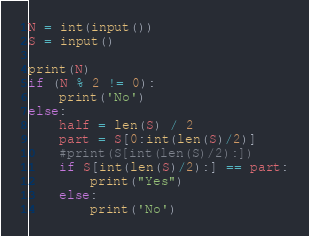<code> <loc_0><loc_0><loc_500><loc_500><_Python_>N = int(input())
S = input()

print(N)
if (N % 2 != 0):
    print('No')
else:
    half = len(S) / 2
    part = S[0:int(len(S)/2)]
    #print(S[int(len(S)/2):])
    if S[int(len(S)/2):] == part:
        print("Yes")
    else:
        print('No')
</code> 